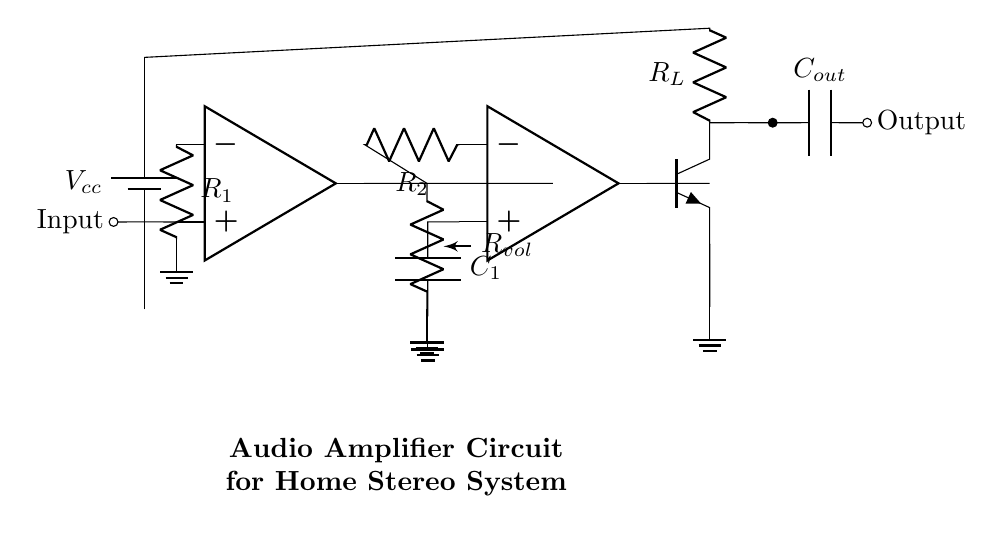What is the power supply voltage in the circuit? The power supply voltage is indicated by the component labeled Vcc, which is connected at the top of the circuit. The value typically represents the voltage necessary for powering the amplifier circuit.
Answer: Vcc What type of components are used in the input stage? The input stage consists of an operational amplifier, an input resistor R1, and connections for inputs and ground. The operational amplifier is crucial for amplifying the input signal.
Answer: Operational amplifier and R1 What role does the volume control resistor play in the circuit? The volume control resistor Rvol is connected to the output of the first operational amplifier, allowing the user to adjust the amplitude of the audio signal before passing it to the next stage. This shows that it's crucial for controlling the overall output volume.
Answer: Adjusts output volume What is the purpose of the capacitor C1 in the tone control stage? C1 is connected in the feedback loop of the second operational amplifier and helps in shaping the frequency response, filtering specific frequencies to enhance tonal quality. Its position indicates that it affects how different frequencies are amplified or attenuated.
Answer: Frequency response shaping How many operational amplifiers are used in this circuit? The circuit diagram shows two operational amplifiers labeled as op amp, which are integral for the amplification stages of the audio signal.
Answer: Two What is connected to the output of the final transistor Q1? The output of the transistor Q1 is connected to the output capacitor Cout, which serves to pass the amplified audio signal while blocking any direct current that might damage connected speakers or equipment.
Answer: Output capacitor Cout What is the load resistor connected to in the output stage? The load resistor RL is connected to the collector of the transistor Q1, which indicates that it helps dissipate power and maintain the desired output characteristics for the load connected to the amplifier circuit.
Answer: Collector of Q1 